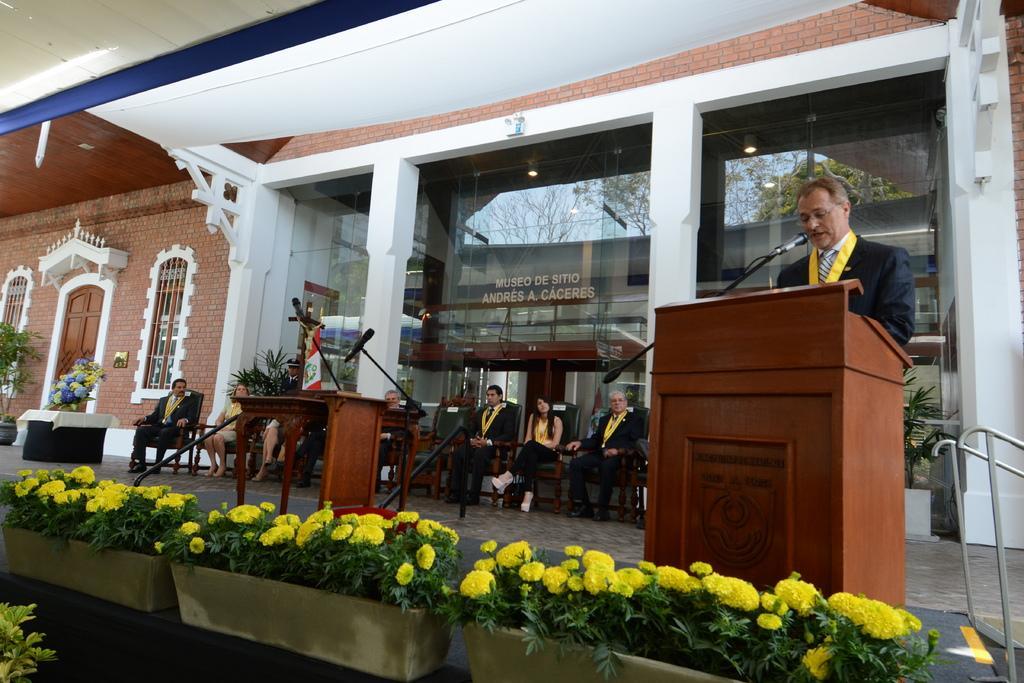In one or two sentences, can you explain what this image depicts? In this image we can see a man standing in front of the podium and also the mike. We can also see the people sitting on the chairs which are on the path. We can also see the plants and also flower pots. In the background we can see the text on the glass window and we can also see the trees in reflection. On the left we can see the door, windows and also the brick wall. Ceiling is also visible. We can also see the lights in reflection. 